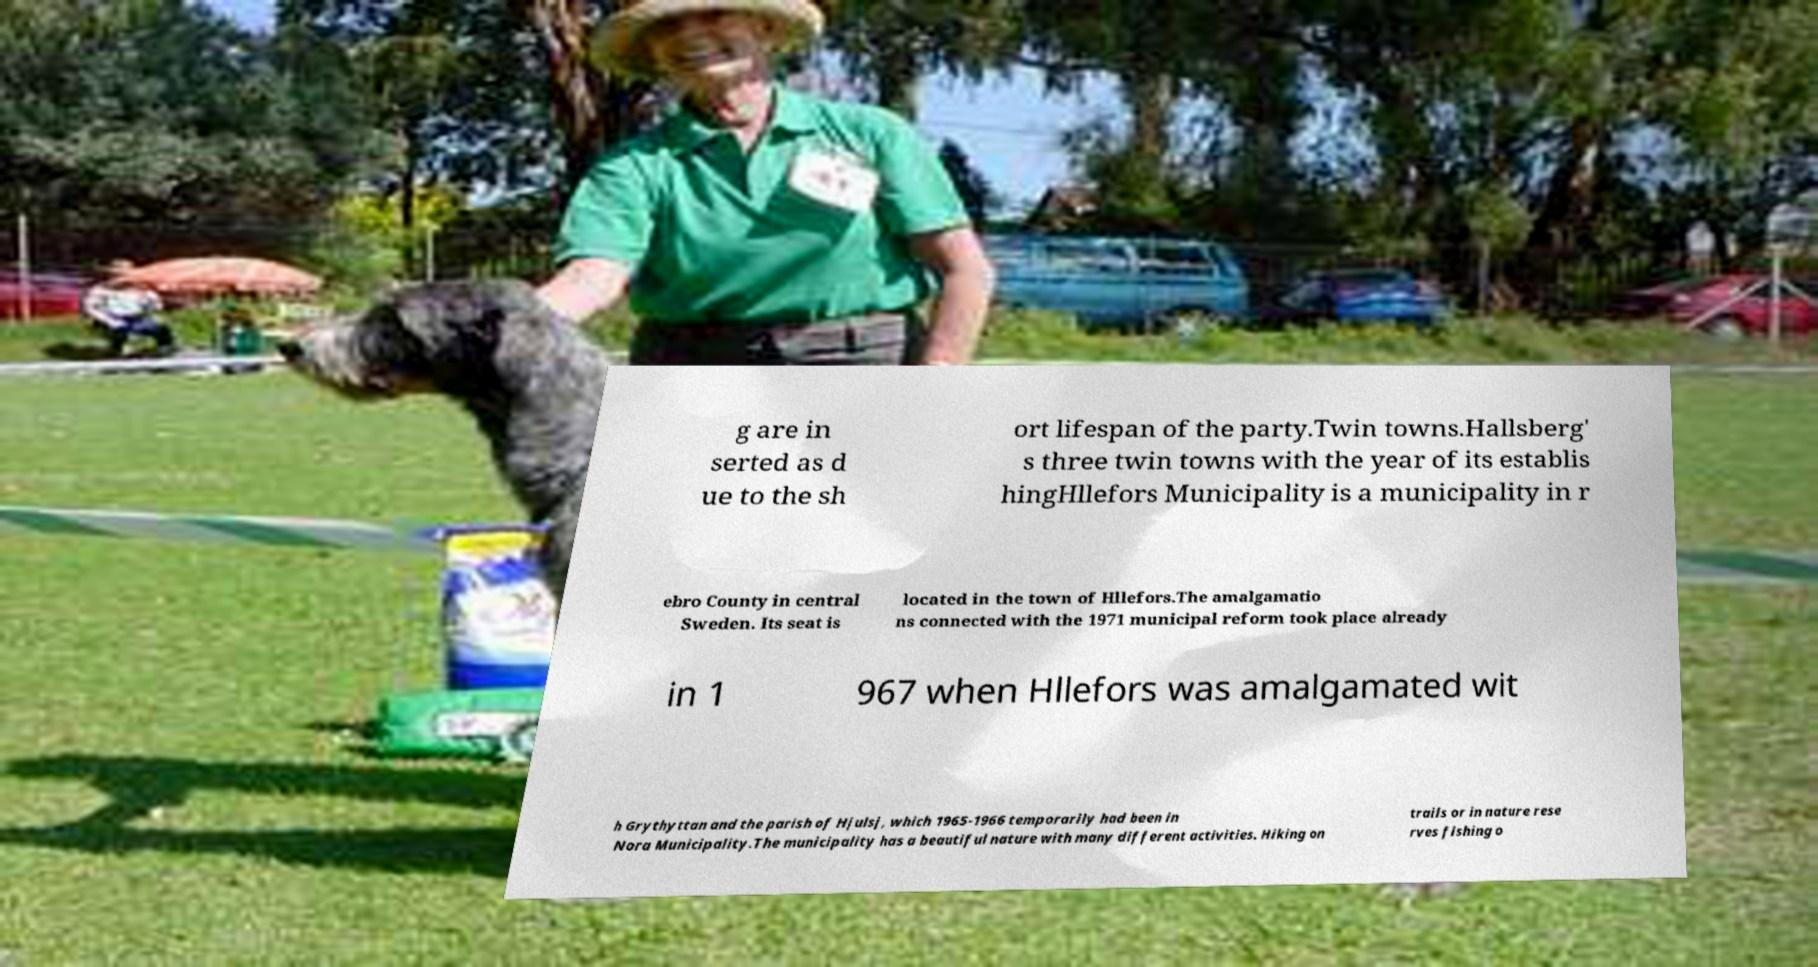Can you accurately transcribe the text from the provided image for me? g are in serted as d ue to the sh ort lifespan of the party.Twin towns.Hallsberg' s three twin towns with the year of its establis hingHllefors Municipality is a municipality in r ebro County in central Sweden. Its seat is located in the town of Hllefors.The amalgamatio ns connected with the 1971 municipal reform took place already in 1 967 when Hllefors was amalgamated wit h Grythyttan and the parish of Hjulsj, which 1965-1966 temporarily had been in Nora Municipality.The municipality has a beautiful nature with many different activities. Hiking on trails or in nature rese rves fishing o 